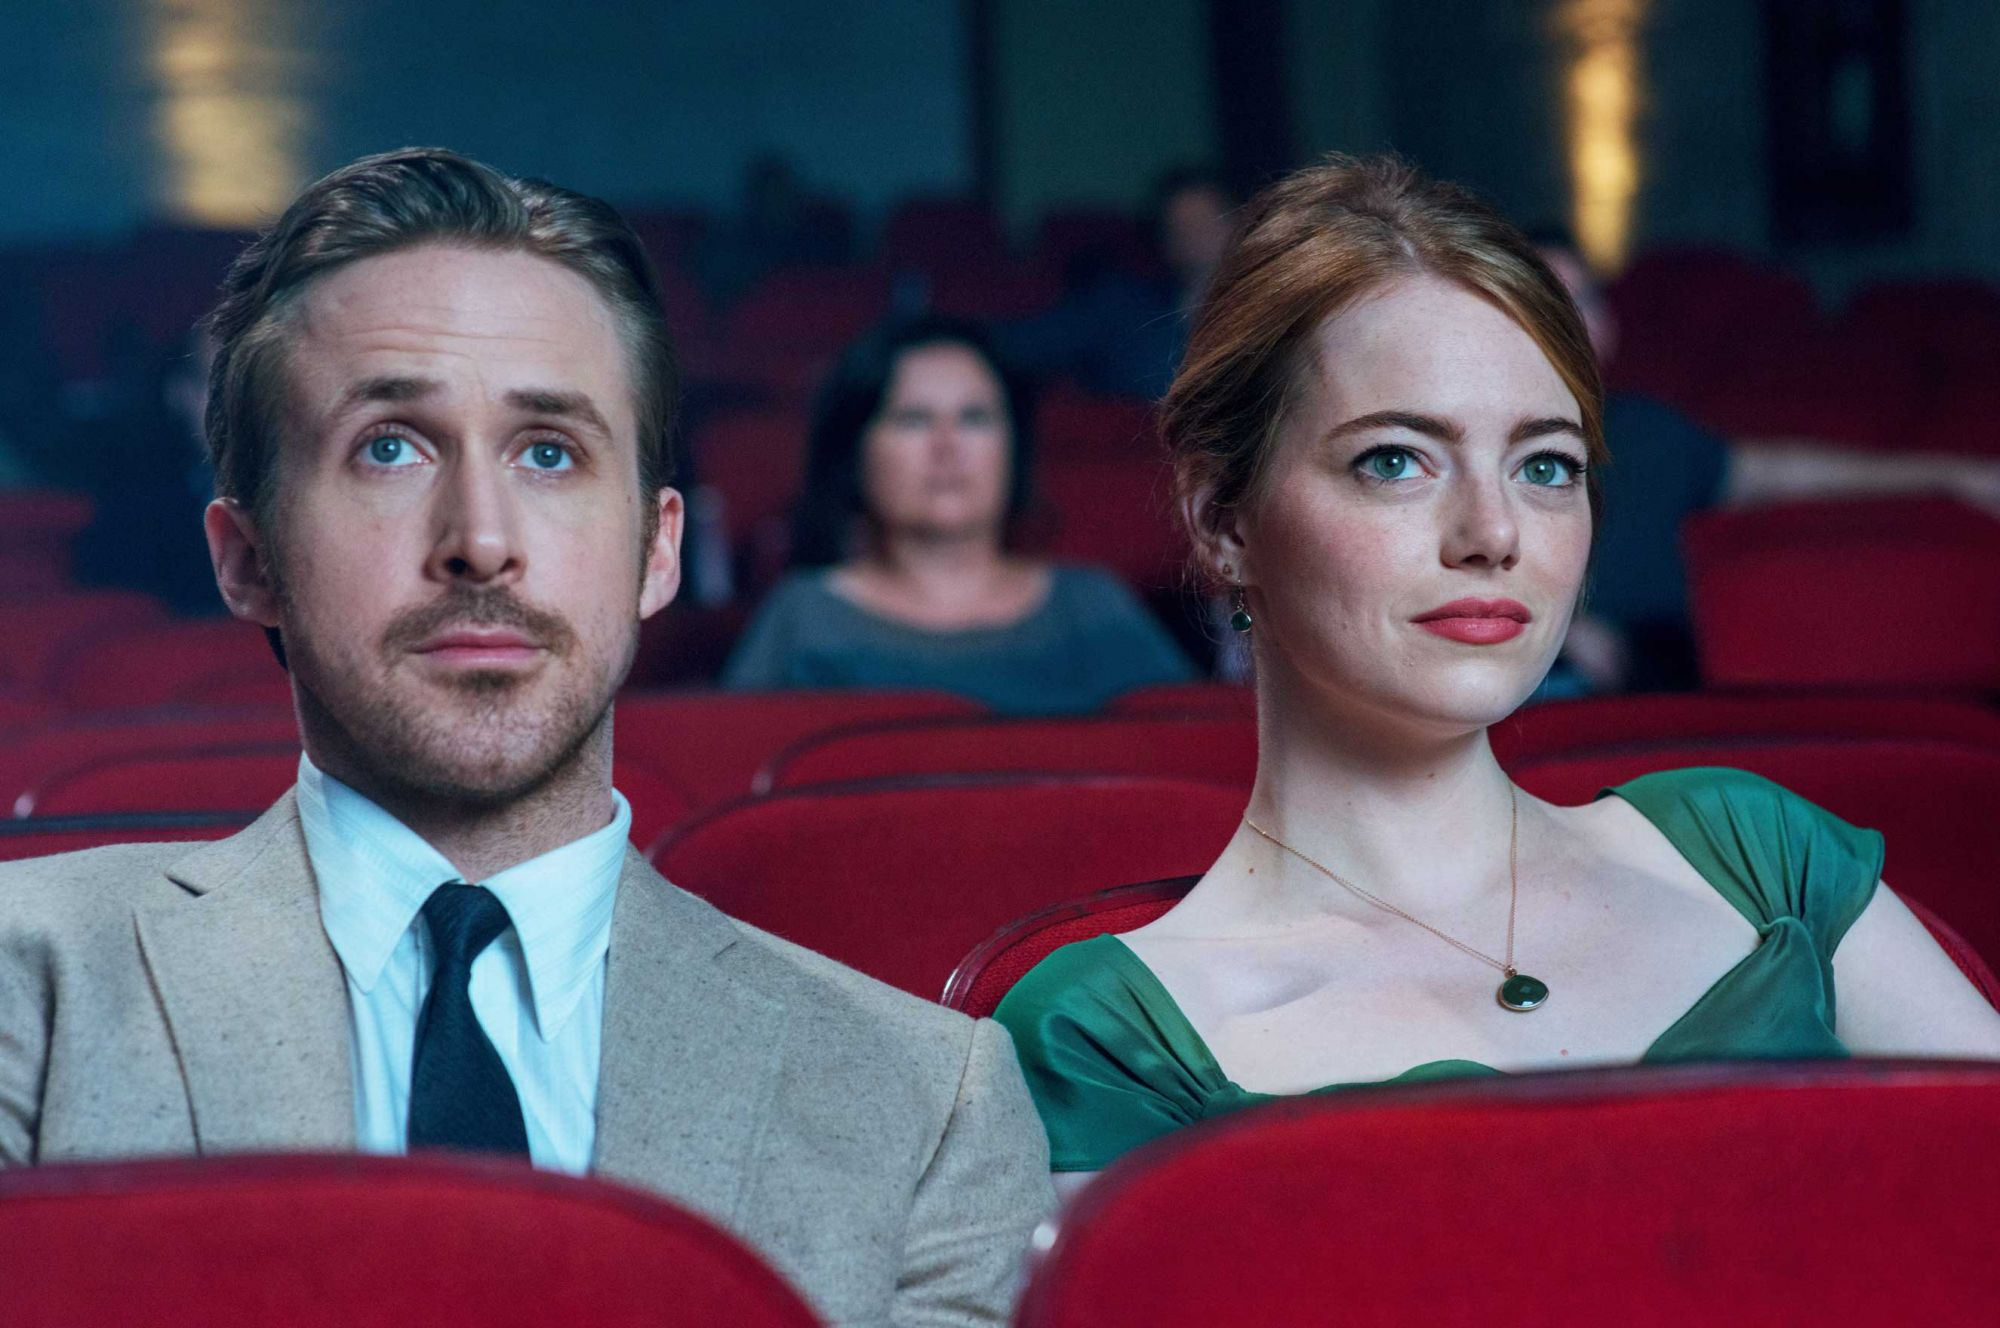Imagine a scenario where Sebastian and Mia are discussing their favorite movies. What kind of conversation do you think they would have? Sebastian, with his deep appreciation for classic jazz and old Hollywood, would likely express his admiration for timeless films such as Casablanca, Singing in the Rain, and The Godfather. He might delve into the nuances of performances and film scores that left a lasting impact. On the other hand, Mia, with her passion for acting and storytelling, could talk about her love for movies that offer compelling narratives and strong female leads, such as Breakfast at Tiffany's, Amélie, and La Dolce Vita. Their conversation would reflect a shared love for cinema and an exploration of different genres and eras that inspire them both. 